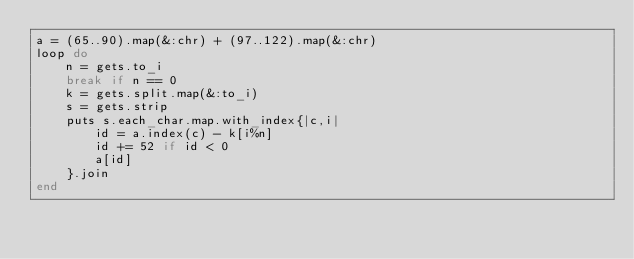Convert code to text. <code><loc_0><loc_0><loc_500><loc_500><_Ruby_>a = (65..90).map(&:chr) + (97..122).map(&:chr)
loop do
    n = gets.to_i
    break if n == 0
    k = gets.split.map(&:to_i)
    s = gets.strip
    puts s.each_char.map.with_index{|c,i|
        id = a.index(c) - k[i%n]
        id += 52 if id < 0
        a[id]
    }.join
end</code> 